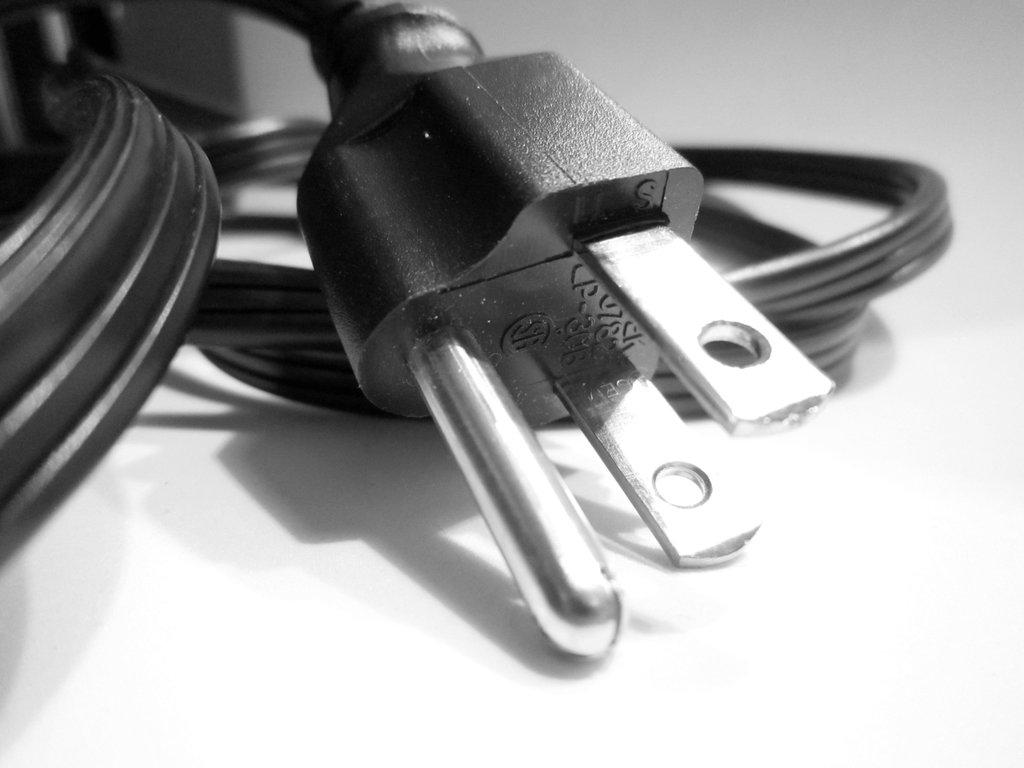What is the main object in the image? There is a wire in the image. What color is the wire? The wire is black in color. What other object is related to the wire in the image? There is a plug in the image. What color is the plug? The plug is black in color. Can you see your brother rowing the boat in the mist in the image? There is no boat, mist, or brother present in the image; it only features a black wire and a black plug. 